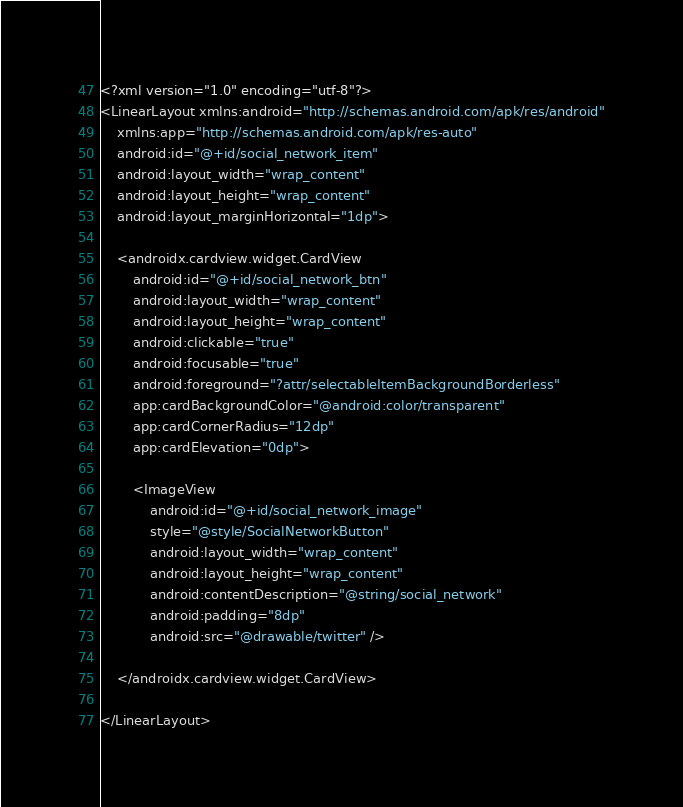<code> <loc_0><loc_0><loc_500><loc_500><_XML_><?xml version="1.0" encoding="utf-8"?>
<LinearLayout xmlns:android="http://schemas.android.com/apk/res/android"
    xmlns:app="http://schemas.android.com/apk/res-auto"
    android:id="@+id/social_network_item"
    android:layout_width="wrap_content"
    android:layout_height="wrap_content"
    android:layout_marginHorizontal="1dp">

    <androidx.cardview.widget.CardView
        android:id="@+id/social_network_btn"
        android:layout_width="wrap_content"
        android:layout_height="wrap_content"
        android:clickable="true"
        android:focusable="true"
        android:foreground="?attr/selectableItemBackgroundBorderless"
        app:cardBackgroundColor="@android:color/transparent"
        app:cardCornerRadius="12dp"
        app:cardElevation="0dp">

        <ImageView
            android:id="@+id/social_network_image"
            style="@style/SocialNetworkButton"
            android:layout_width="wrap_content"
            android:layout_height="wrap_content"
            android:contentDescription="@string/social_network"
            android:padding="8dp"
            android:src="@drawable/twitter" />

    </androidx.cardview.widget.CardView>

</LinearLayout></code> 